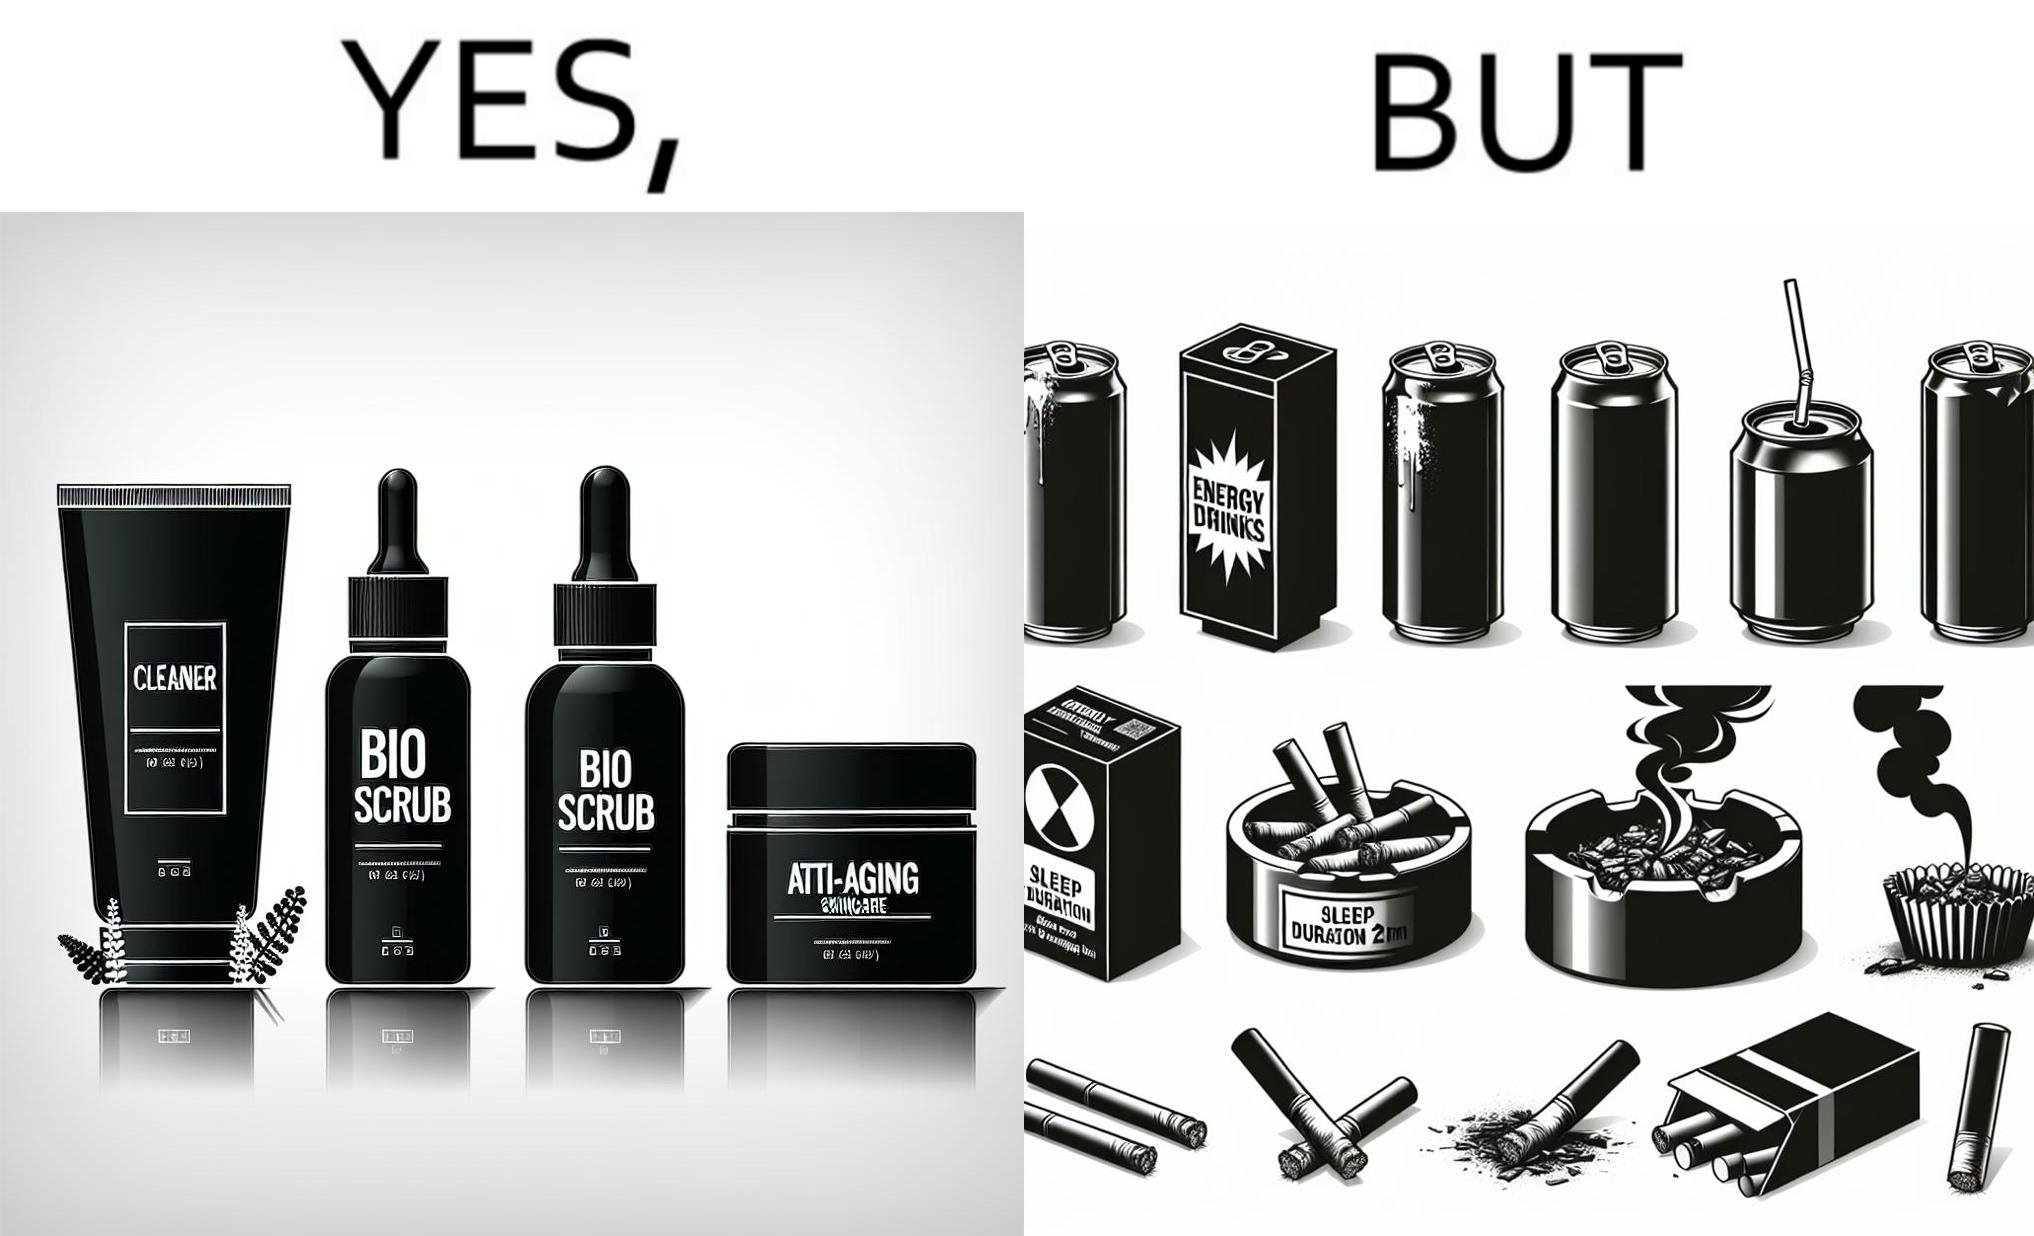Describe the content of this image. This image is ironic as on the one hand, the presumed person is into skincare and wants to do the best for their skin, which is good, but on the other hand, they are involved in unhealthy habits that will damage their skin like smoking, caffeine and inadequate sleep. 